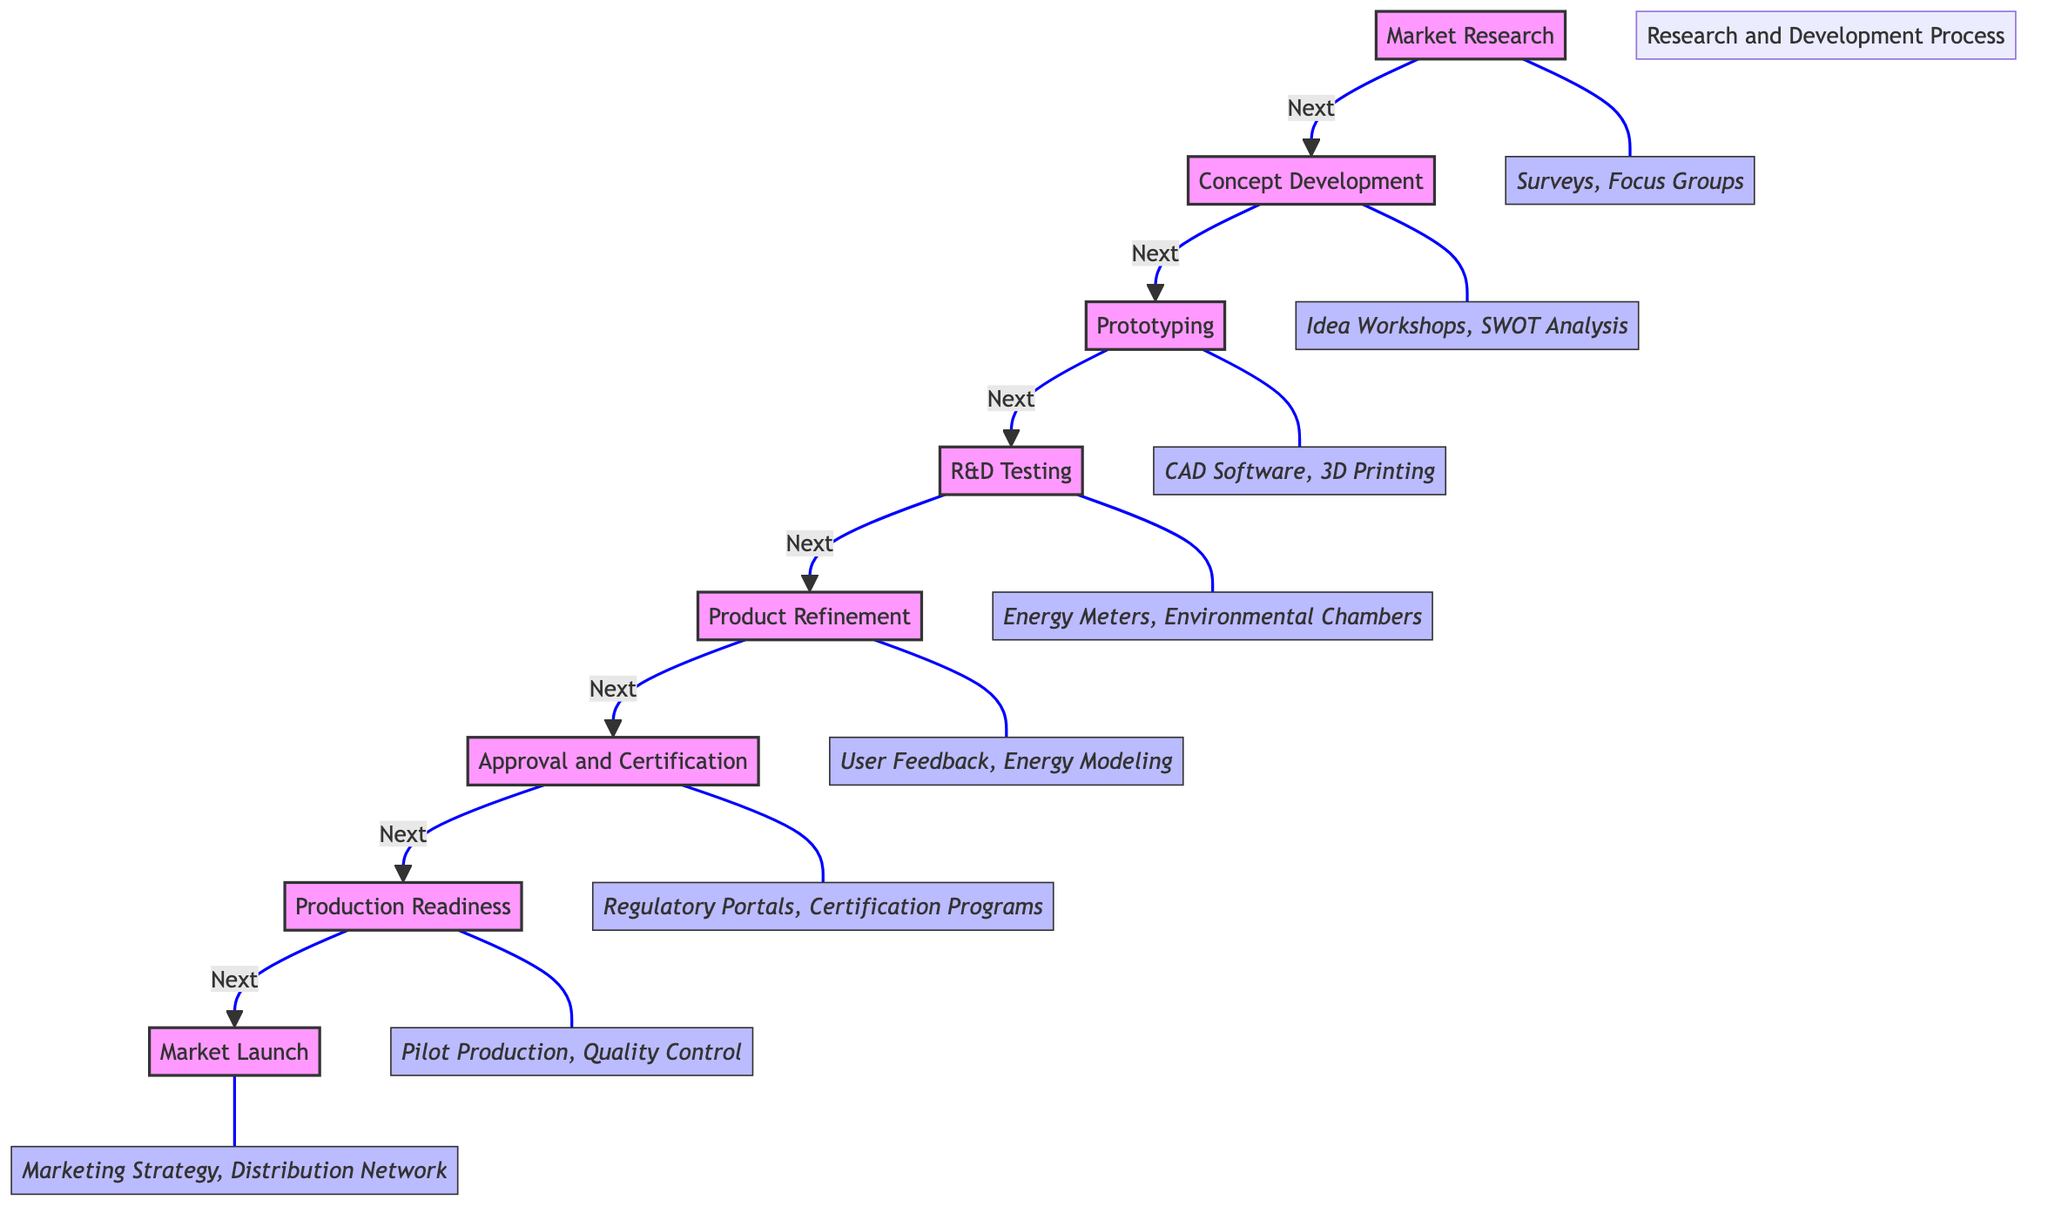What is the first step in the Research and Development Process? The diagram begins with "Market Research" as the first step, indicated by the position at the top.
Answer: Market Research How many main nodes are there in the diagram? There are eight main nodes representing distinct stages of the Research and Development Process, all of which are connected sequentially.
Answer: Eight What tools are associated with R&D Testing? The tools listed under R&D Testing in the diagram include "Energy Consumption Meters" and "Environmental Chambers."
Answer: Energy Meters, Environmental Chambers What is the last activity before Market Launch? According to the flow of the diagram, "Production Readiness" is the last step before moving on to Market Launch.
Answer: Production Readiness Which activity directly follows Prototyping? The diagram shows that "R&D Testing" directly follows the "Prototyping" stage, as indicated by the directional flow between them.
Answer: R&D Testing What is one of the activities in Concept Development? One of the activities listed under Concept Development is "Brainstorm innovative ideas," which is explicitly mentioned in the activities for this node.
Answer: Brainstorm innovative ideas What tools are used during the Approval and Certification phase? The tools mentioned for the Approval and Certification phase include "Regulatory Submission Portals" and "Certification Programs."
Answer: Regulatory Portals, Certification Programs What comes before Product Refinement? Based on the flow, "R&D Testing" is the stage that precedes "Product Refinement," leading into the development and enhancement of the product.
Answer: R&D Testing What is a key activity in the Market Launch phase? One key activity in the Market Launch phase is "Marketing campaign development," as highlighted under the activities for this final node.
Answer: Marketing campaign development 